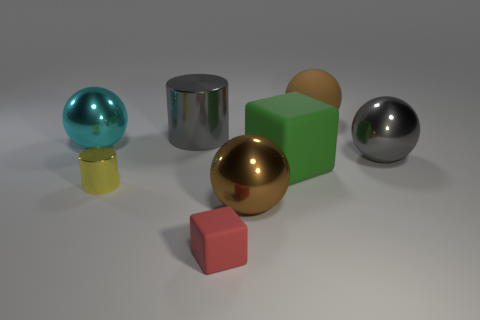Subtract 1 spheres. How many spheres are left? 3 Subtract all red cubes. Subtract all purple cylinders. How many cubes are left? 1 Add 1 matte things. How many objects exist? 9 Subtract all cylinders. How many objects are left? 6 Add 6 large brown metallic spheres. How many large brown metallic spheres are left? 7 Add 2 large gray metallic cylinders. How many large gray metallic cylinders exist? 3 Subtract 0 red balls. How many objects are left? 8 Subtract all red matte objects. Subtract all tiny yellow rubber balls. How many objects are left? 7 